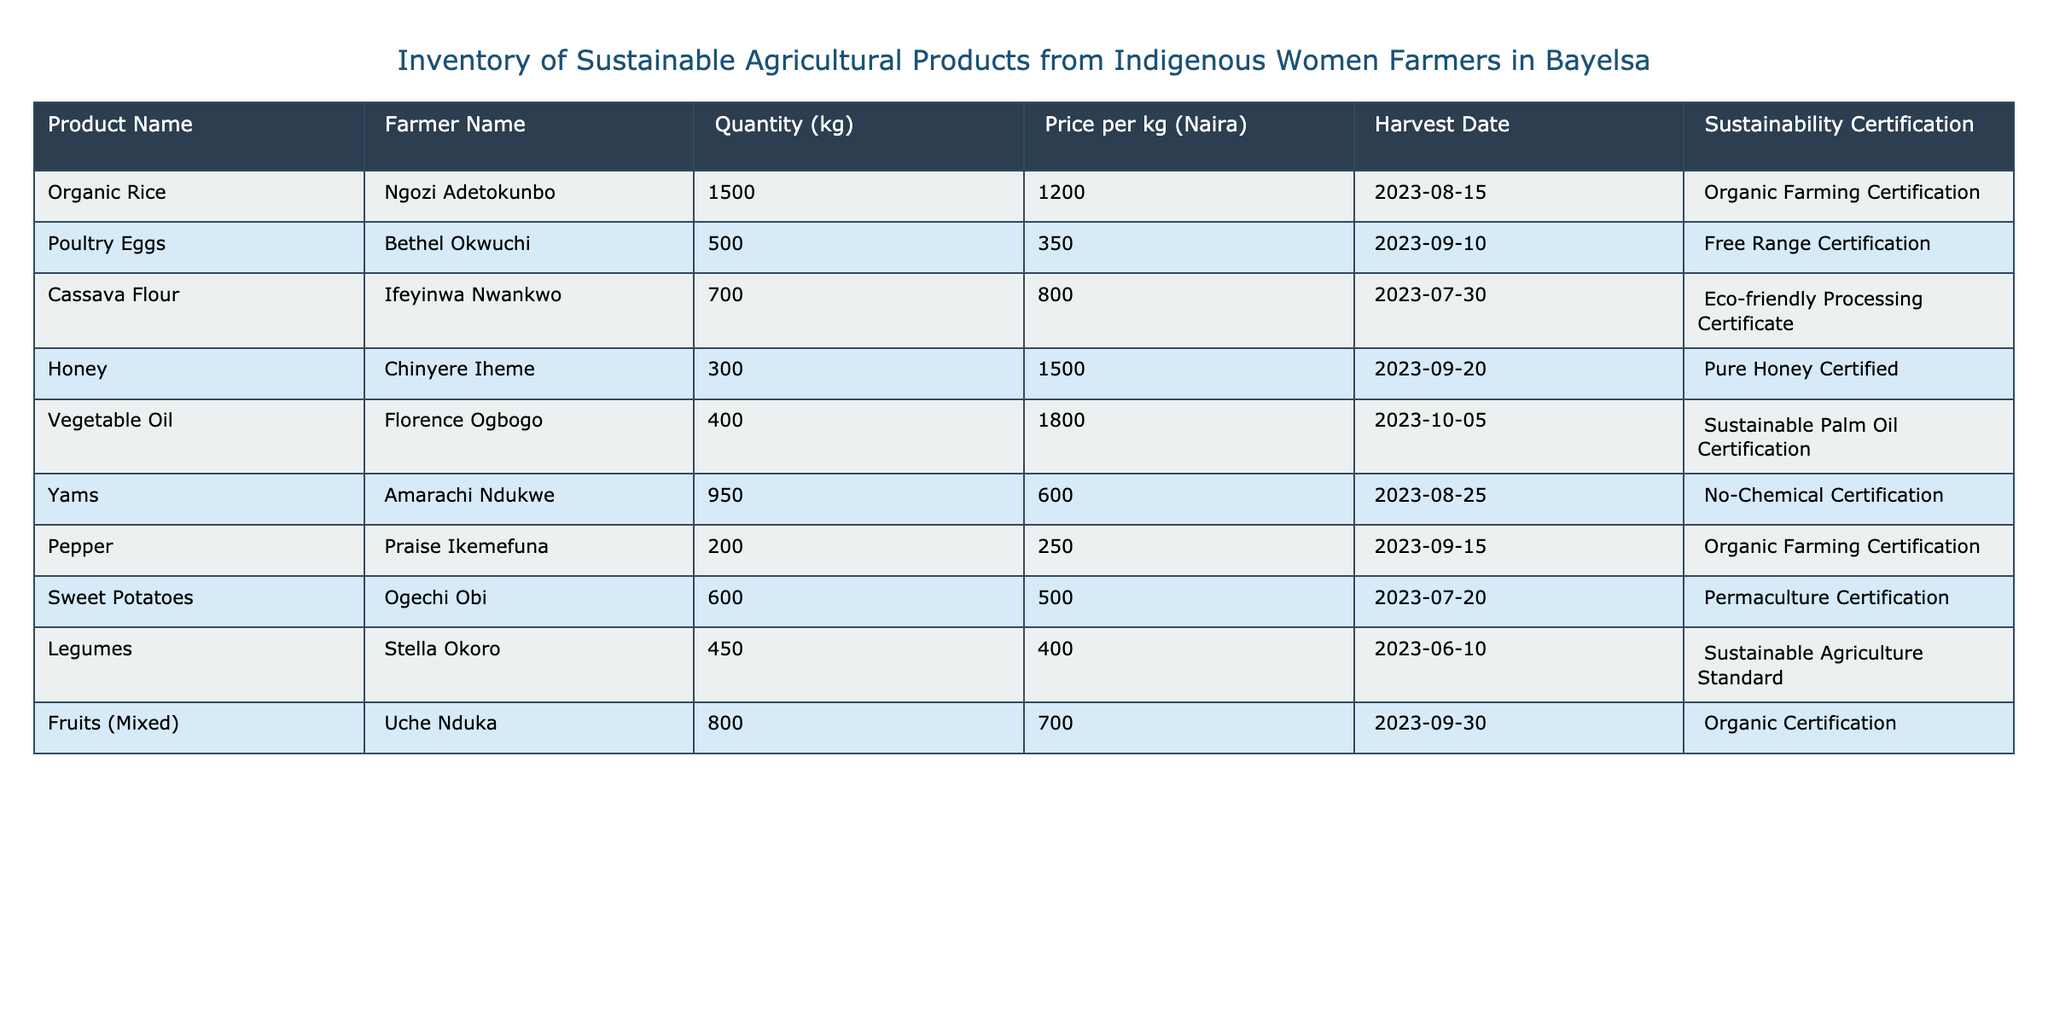What is the price per kg of organic rice? The table shows the product name "Organic Rice" alongside its details, including the price per kg, which is listed as 1200 Naira.
Answer: 1200 Naira How many kilograms of yams are in the inventory? The entry for "Yams" in the table indicates that there are 950 kilograms available.
Answer: 950 kg What is the total quantity of poultry eggs and honey combined? To find the total, add the quantity of "Poultry Eggs" (500 kg) and "Honey" (300 kg). The sum is 500 + 300 = 800 kg.
Answer: 800 kg Is cassava flour certified as eco-friendly? The entry for "Cassava Flour" mentions an "Eco-friendly Processing Certificate," indicating that it is indeed certified eco-friendly.
Answer: Yes Which product has the highest price per kg? By examining the price per kg column, "Honey" has the highest price listed at 1500 Naira, compared to others.
Answer: Honey What is the average quantity of products listed in the inventory? To find the average quantity, sum the quantities: 1500 + 500 + 700 + 300 + 400 + 950 + 200 + 600 + 450 + 800 = 5100 kg. Then, divide by the number of products (10): 5100 / 10 = 510 kg.
Answer: 510 kg Are there any products that have a sustainability certification related to organic farming? The table includes "Organic Rice" and "Pepper," both of which are certified under "Organic Farming Certification."
Answer: Yes Which farmer produced the highest quantity of product? By reviewing the quantity column, "Ngozi Adetokunbo" produced the highest quantity with 1500 kg of organic rice.
Answer: Ngozi Adetokunbo What is the difference in price between the most and least expensive products? The most expensive product is "Honey" at 1500 Naira, and the least expensive is "Pepper" at 250 Naira. The difference is 1500 - 250 = 1250 Naira.
Answer: 1250 Naira 